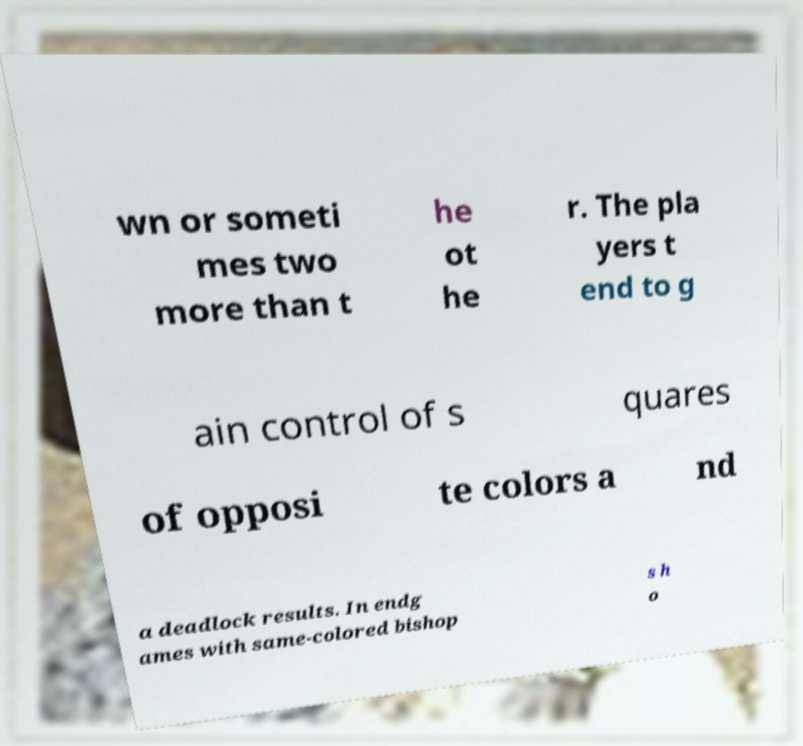Can you accurately transcribe the text from the provided image for me? wn or someti mes two more than t he ot he r. The pla yers t end to g ain control of s quares of opposi te colors a nd a deadlock results. In endg ames with same-colored bishop s h o 